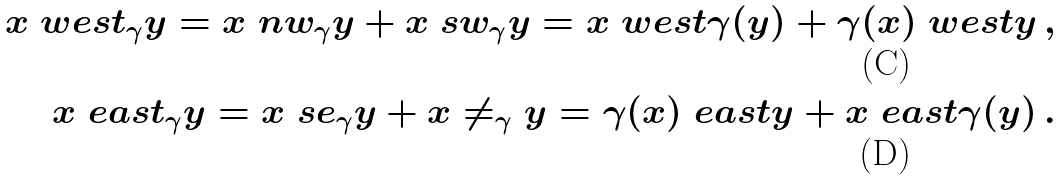<formula> <loc_0><loc_0><loc_500><loc_500>x \ w e s t _ { \gamma } y = x \ n w _ { \gamma } y + x \ s w _ { \gamma } y = x \ w e s t \gamma ( y ) + \gamma ( x ) \ w e s t y \, , \\ x \ e a s t _ { \gamma } y = x \ s e _ { \gamma } y + x \ne _ { \gamma } y = \gamma ( x ) \ e a s t y + x \ e a s t \gamma ( y ) \, .</formula> 